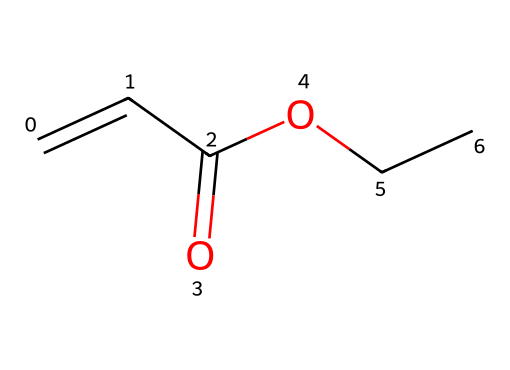How many carbon atoms are present in the structure? Count the number of "C" in the SMILES representation: C=CC(=O)OCC. There are four carbon atoms depicted in the structure.
Answer: four What functional group is present in this molecule? Identify the parts of the structure: the "C(=O)O" portion indicates the presence of a carboxylic acid functional group (due to the carbonyl and hydroxyl components).
Answer: carboxylic acid How many total hydrogen atoms are in the compound? Analyze the structure based on valency rules: Typically, a carbon atom makes four bonds. With four carbons and considering the double bond and functional groups, there are a total of eight hydrogen atoms when counted accurately.
Answer: eight Is this compound soluble in water? Non-electrolytes, like this compound, usually have limited solubility in water, but due to the polar carboxylic acid group present, it tends to be more soluble than typical non-electrolytes.
Answer: yes What type of bonding is primarily present in this structure? Look at the types of bonds in the structure: There are covalent bonds indicated by the connections between carbon, hydrogen, and oxygen atoms; no ionic or metallic bonds appear. Thus, covalent bonding is the predominant type.
Answer: covalent What is the molecular formula derived from this SMILES? From the concrete structure, count the atoms applied in typical chemical notation: C4H8O2 encapsulates the elements in their entirety, indicating the chemical makeup represented in a formula.
Answer: C4H8O2 